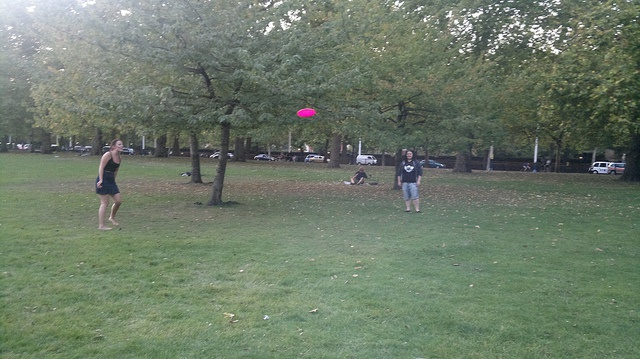Describe the objects in this image and their specific colors. I can see people in white, gray, darkgray, and black tones, people in white, black, gray, and darkgray tones, truck in white, black, darkgray, and lavender tones, people in white, gray, black, and darkgray tones, and car in white, black, darkgray, and lavender tones in this image. 